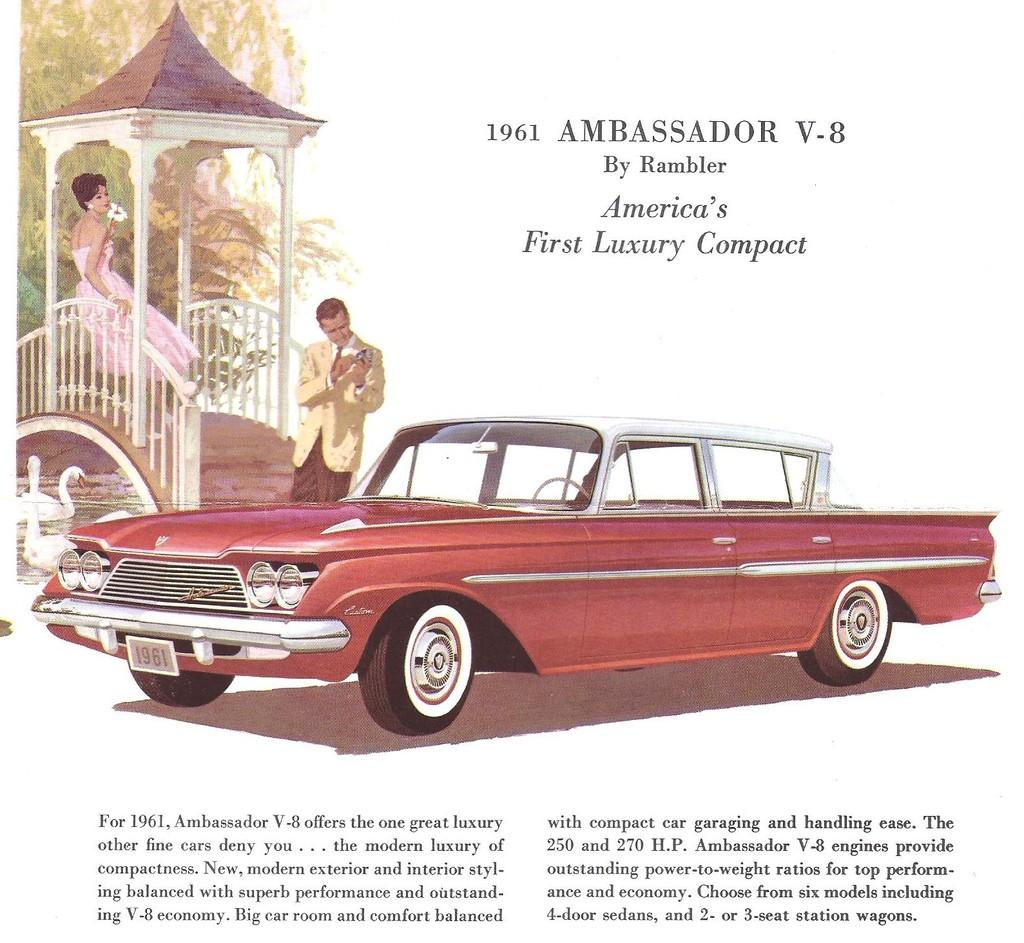What is in the foreground of the poster? There is text, a car, a man, and a woman standing on a bridge in the foreground of the poster. What is the woman doing in the foreground of the poster? The woman is standing on a bridge in the foreground of the poster. What can be seen under the bridge in the foreground of the poster? There are ducks on the water under the bridge. What is visible in the background of the poster? There are trees in the background of the poster. What type of pancake is being served on the bridge in the image? There is no pancake present in the image; it features a car, a man, a woman on a bridge, ducks on the water, and trees in the background. Can you see any blood on the car in the image? There is no blood visible on the car in the image. 